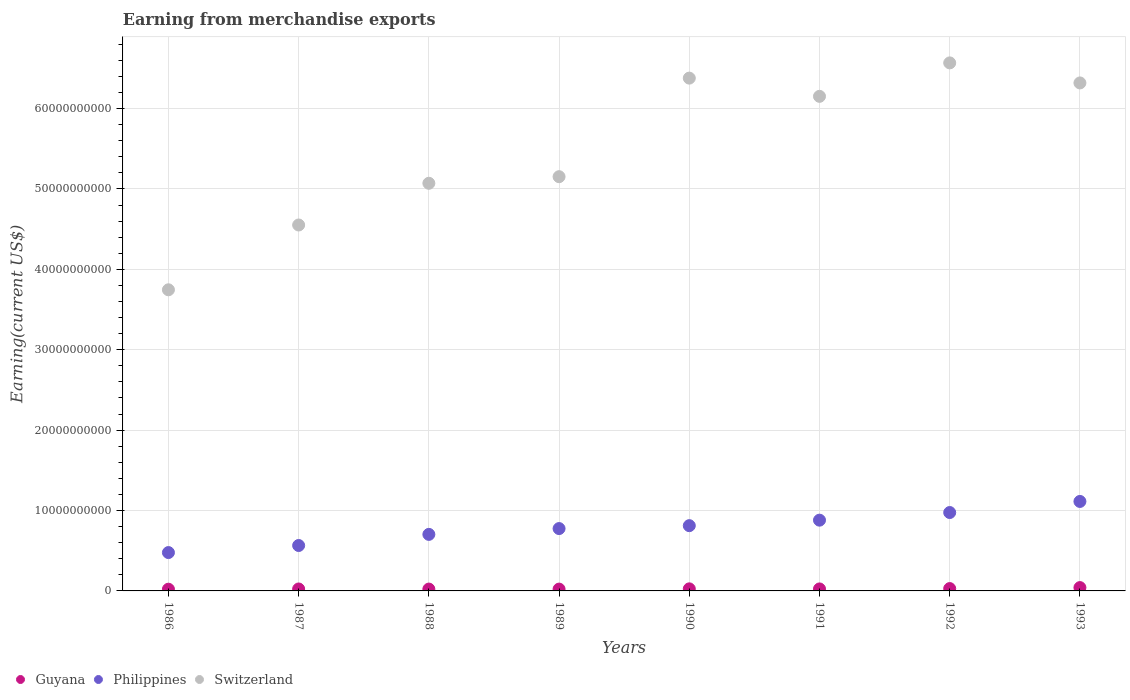How many different coloured dotlines are there?
Keep it short and to the point. 3. Is the number of dotlines equal to the number of legend labels?
Your answer should be very brief. Yes. What is the amount earned from merchandise exports in Switzerland in 1988?
Your response must be concise. 5.07e+1. Across all years, what is the maximum amount earned from merchandise exports in Guyana?
Offer a very short reply. 4.14e+08. Across all years, what is the minimum amount earned from merchandise exports in Philippines?
Give a very brief answer. 4.77e+09. In which year was the amount earned from merchandise exports in Switzerland maximum?
Your response must be concise. 1992. What is the total amount earned from merchandise exports in Guyana in the graph?
Ensure brevity in your answer.  2.12e+09. What is the difference between the amount earned from merchandise exports in Switzerland in 1986 and that in 1991?
Offer a very short reply. -2.41e+1. What is the difference between the amount earned from merchandise exports in Philippines in 1993 and the amount earned from merchandise exports in Guyana in 1992?
Offer a very short reply. 1.08e+1. What is the average amount earned from merchandise exports in Switzerland per year?
Give a very brief answer. 5.49e+1. In the year 1988, what is the difference between the amount earned from merchandise exports in Switzerland and amount earned from merchandise exports in Guyana?
Ensure brevity in your answer.  5.05e+1. In how many years, is the amount earned from merchandise exports in Guyana greater than 54000000000 US$?
Your answer should be compact. 0. What is the ratio of the amount earned from merchandise exports in Switzerland in 1986 to that in 1988?
Give a very brief answer. 0.74. Is the difference between the amount earned from merchandise exports in Switzerland in 1991 and 1993 greater than the difference between the amount earned from merchandise exports in Guyana in 1991 and 1993?
Provide a succinct answer. No. What is the difference between the highest and the second highest amount earned from merchandise exports in Philippines?
Provide a short and direct response. 1.38e+09. What is the difference between the highest and the lowest amount earned from merchandise exports in Guyana?
Your answer should be very brief. 2.00e+08. Is it the case that in every year, the sum of the amount earned from merchandise exports in Philippines and amount earned from merchandise exports in Guyana  is greater than the amount earned from merchandise exports in Switzerland?
Make the answer very short. No. Does the amount earned from merchandise exports in Philippines monotonically increase over the years?
Keep it short and to the point. Yes. Is the amount earned from merchandise exports in Switzerland strictly greater than the amount earned from merchandise exports in Philippines over the years?
Ensure brevity in your answer.  Yes. Is the amount earned from merchandise exports in Guyana strictly less than the amount earned from merchandise exports in Philippines over the years?
Offer a terse response. Yes. How many dotlines are there?
Ensure brevity in your answer.  3. What is the difference between two consecutive major ticks on the Y-axis?
Provide a short and direct response. 1.00e+1. Does the graph contain any zero values?
Provide a short and direct response. No. Where does the legend appear in the graph?
Your response must be concise. Bottom left. How are the legend labels stacked?
Your answer should be very brief. Horizontal. What is the title of the graph?
Provide a succinct answer. Earning from merchandise exports. Does "Korea (Democratic)" appear as one of the legend labels in the graph?
Offer a very short reply. No. What is the label or title of the Y-axis?
Ensure brevity in your answer.  Earning(current US$). What is the Earning(current US$) in Guyana in 1986?
Make the answer very short. 2.14e+08. What is the Earning(current US$) of Philippines in 1986?
Your answer should be very brief. 4.77e+09. What is the Earning(current US$) of Switzerland in 1986?
Provide a succinct answer. 3.75e+1. What is the Earning(current US$) of Guyana in 1987?
Provide a succinct answer. 2.42e+08. What is the Earning(current US$) of Philippines in 1987?
Provide a succinct answer. 5.65e+09. What is the Earning(current US$) of Switzerland in 1987?
Your answer should be very brief. 4.55e+1. What is the Earning(current US$) in Guyana in 1988?
Make the answer very short. 2.30e+08. What is the Earning(current US$) of Philippines in 1988?
Offer a very short reply. 7.03e+09. What is the Earning(current US$) of Switzerland in 1988?
Offer a very short reply. 5.07e+1. What is the Earning(current US$) in Guyana in 1989?
Offer a terse response. 2.27e+08. What is the Earning(current US$) in Philippines in 1989?
Your answer should be compact. 7.76e+09. What is the Earning(current US$) in Switzerland in 1989?
Offer a very short reply. 5.15e+1. What is the Earning(current US$) of Guyana in 1990?
Offer a very short reply. 2.57e+08. What is the Earning(current US$) in Philippines in 1990?
Keep it short and to the point. 8.12e+09. What is the Earning(current US$) in Switzerland in 1990?
Your answer should be compact. 6.38e+1. What is the Earning(current US$) in Guyana in 1991?
Keep it short and to the point. 2.48e+08. What is the Earning(current US$) in Philippines in 1991?
Your answer should be compact. 8.80e+09. What is the Earning(current US$) in Switzerland in 1991?
Provide a short and direct response. 6.15e+1. What is the Earning(current US$) of Guyana in 1992?
Keep it short and to the point. 2.92e+08. What is the Earning(current US$) in Philippines in 1992?
Give a very brief answer. 9.75e+09. What is the Earning(current US$) in Switzerland in 1992?
Offer a very short reply. 6.57e+1. What is the Earning(current US$) of Guyana in 1993?
Keep it short and to the point. 4.14e+08. What is the Earning(current US$) of Philippines in 1993?
Offer a terse response. 1.11e+1. What is the Earning(current US$) in Switzerland in 1993?
Make the answer very short. 6.32e+1. Across all years, what is the maximum Earning(current US$) of Guyana?
Provide a succinct answer. 4.14e+08. Across all years, what is the maximum Earning(current US$) in Philippines?
Keep it short and to the point. 1.11e+1. Across all years, what is the maximum Earning(current US$) in Switzerland?
Make the answer very short. 6.57e+1. Across all years, what is the minimum Earning(current US$) of Guyana?
Ensure brevity in your answer.  2.14e+08. Across all years, what is the minimum Earning(current US$) of Philippines?
Your answer should be very brief. 4.77e+09. Across all years, what is the minimum Earning(current US$) in Switzerland?
Your answer should be compact. 3.75e+1. What is the total Earning(current US$) of Guyana in the graph?
Offer a terse response. 2.12e+09. What is the total Earning(current US$) of Philippines in the graph?
Keep it short and to the point. 6.30e+1. What is the total Earning(current US$) in Switzerland in the graph?
Provide a short and direct response. 4.39e+11. What is the difference between the Earning(current US$) in Guyana in 1986 and that in 1987?
Your answer should be compact. -2.80e+07. What is the difference between the Earning(current US$) in Philippines in 1986 and that in 1987?
Make the answer very short. -8.78e+08. What is the difference between the Earning(current US$) of Switzerland in 1986 and that in 1987?
Your answer should be very brief. -8.06e+09. What is the difference between the Earning(current US$) in Guyana in 1986 and that in 1988?
Your answer should be compact. -1.60e+07. What is the difference between the Earning(current US$) of Philippines in 1986 and that in 1988?
Provide a short and direct response. -2.26e+09. What is the difference between the Earning(current US$) in Switzerland in 1986 and that in 1988?
Your response must be concise. -1.32e+1. What is the difference between the Earning(current US$) of Guyana in 1986 and that in 1989?
Give a very brief answer. -1.30e+07. What is the difference between the Earning(current US$) in Philippines in 1986 and that in 1989?
Your answer should be very brief. -2.98e+09. What is the difference between the Earning(current US$) in Switzerland in 1986 and that in 1989?
Provide a succinct answer. -1.41e+1. What is the difference between the Earning(current US$) in Guyana in 1986 and that in 1990?
Your answer should be compact. -4.30e+07. What is the difference between the Earning(current US$) of Philippines in 1986 and that in 1990?
Offer a very short reply. -3.35e+09. What is the difference between the Earning(current US$) in Switzerland in 1986 and that in 1990?
Your response must be concise. -2.63e+1. What is the difference between the Earning(current US$) of Guyana in 1986 and that in 1991?
Provide a succinct answer. -3.40e+07. What is the difference between the Earning(current US$) in Philippines in 1986 and that in 1991?
Your response must be concise. -4.03e+09. What is the difference between the Earning(current US$) of Switzerland in 1986 and that in 1991?
Offer a very short reply. -2.41e+1. What is the difference between the Earning(current US$) of Guyana in 1986 and that in 1992?
Give a very brief answer. -7.80e+07. What is the difference between the Earning(current US$) of Philippines in 1986 and that in 1992?
Make the answer very short. -4.98e+09. What is the difference between the Earning(current US$) in Switzerland in 1986 and that in 1992?
Offer a very short reply. -2.82e+1. What is the difference between the Earning(current US$) of Guyana in 1986 and that in 1993?
Make the answer very short. -2.00e+08. What is the difference between the Earning(current US$) in Philippines in 1986 and that in 1993?
Ensure brevity in your answer.  -6.36e+09. What is the difference between the Earning(current US$) in Switzerland in 1986 and that in 1993?
Your response must be concise. -2.57e+1. What is the difference between the Earning(current US$) in Philippines in 1987 and that in 1988?
Offer a very short reply. -1.38e+09. What is the difference between the Earning(current US$) of Switzerland in 1987 and that in 1988?
Give a very brief answer. -5.19e+09. What is the difference between the Earning(current US$) in Guyana in 1987 and that in 1989?
Your answer should be compact. 1.50e+07. What is the difference between the Earning(current US$) of Philippines in 1987 and that in 1989?
Your response must be concise. -2.11e+09. What is the difference between the Earning(current US$) in Switzerland in 1987 and that in 1989?
Provide a succinct answer. -6.01e+09. What is the difference between the Earning(current US$) in Guyana in 1987 and that in 1990?
Give a very brief answer. -1.50e+07. What is the difference between the Earning(current US$) in Philippines in 1987 and that in 1990?
Offer a terse response. -2.47e+09. What is the difference between the Earning(current US$) in Switzerland in 1987 and that in 1990?
Make the answer very short. -1.83e+1. What is the difference between the Earning(current US$) of Guyana in 1987 and that in 1991?
Offer a very short reply. -6.00e+06. What is the difference between the Earning(current US$) in Philippines in 1987 and that in 1991?
Your answer should be very brief. -3.15e+09. What is the difference between the Earning(current US$) of Switzerland in 1987 and that in 1991?
Provide a short and direct response. -1.60e+1. What is the difference between the Earning(current US$) in Guyana in 1987 and that in 1992?
Ensure brevity in your answer.  -5.00e+07. What is the difference between the Earning(current US$) in Philippines in 1987 and that in 1992?
Your answer should be compact. -4.10e+09. What is the difference between the Earning(current US$) of Switzerland in 1987 and that in 1992?
Provide a succinct answer. -2.02e+1. What is the difference between the Earning(current US$) of Guyana in 1987 and that in 1993?
Give a very brief answer. -1.72e+08. What is the difference between the Earning(current US$) of Philippines in 1987 and that in 1993?
Offer a terse response. -5.48e+09. What is the difference between the Earning(current US$) of Switzerland in 1987 and that in 1993?
Your answer should be compact. -1.77e+1. What is the difference between the Earning(current US$) in Guyana in 1988 and that in 1989?
Offer a terse response. 3.00e+06. What is the difference between the Earning(current US$) in Philippines in 1988 and that in 1989?
Provide a short and direct response. -7.23e+08. What is the difference between the Earning(current US$) in Switzerland in 1988 and that in 1989?
Give a very brief answer. -8.21e+08. What is the difference between the Earning(current US$) of Guyana in 1988 and that in 1990?
Your answer should be very brief. -2.70e+07. What is the difference between the Earning(current US$) in Philippines in 1988 and that in 1990?
Provide a short and direct response. -1.08e+09. What is the difference between the Earning(current US$) of Switzerland in 1988 and that in 1990?
Offer a very short reply. -1.31e+1. What is the difference between the Earning(current US$) in Guyana in 1988 and that in 1991?
Keep it short and to the point. -1.80e+07. What is the difference between the Earning(current US$) of Philippines in 1988 and that in 1991?
Offer a very short reply. -1.77e+09. What is the difference between the Earning(current US$) of Switzerland in 1988 and that in 1991?
Provide a succinct answer. -1.08e+1. What is the difference between the Earning(current US$) in Guyana in 1988 and that in 1992?
Your response must be concise. -6.20e+07. What is the difference between the Earning(current US$) of Philippines in 1988 and that in 1992?
Keep it short and to the point. -2.72e+09. What is the difference between the Earning(current US$) of Switzerland in 1988 and that in 1992?
Keep it short and to the point. -1.50e+1. What is the difference between the Earning(current US$) in Guyana in 1988 and that in 1993?
Make the answer very short. -1.84e+08. What is the difference between the Earning(current US$) in Philippines in 1988 and that in 1993?
Provide a succinct answer. -4.10e+09. What is the difference between the Earning(current US$) of Switzerland in 1988 and that in 1993?
Make the answer very short. -1.25e+1. What is the difference between the Earning(current US$) in Guyana in 1989 and that in 1990?
Your answer should be compact. -3.00e+07. What is the difference between the Earning(current US$) of Philippines in 1989 and that in 1990?
Your answer should be compact. -3.62e+08. What is the difference between the Earning(current US$) of Switzerland in 1989 and that in 1990?
Make the answer very short. -1.23e+1. What is the difference between the Earning(current US$) in Guyana in 1989 and that in 1991?
Give a very brief answer. -2.10e+07. What is the difference between the Earning(current US$) of Philippines in 1989 and that in 1991?
Provide a short and direct response. -1.05e+09. What is the difference between the Earning(current US$) of Switzerland in 1989 and that in 1991?
Ensure brevity in your answer.  -9.99e+09. What is the difference between the Earning(current US$) in Guyana in 1989 and that in 1992?
Provide a short and direct response. -6.50e+07. What is the difference between the Earning(current US$) in Philippines in 1989 and that in 1992?
Provide a succinct answer. -2.00e+09. What is the difference between the Earning(current US$) in Switzerland in 1989 and that in 1992?
Ensure brevity in your answer.  -1.42e+1. What is the difference between the Earning(current US$) of Guyana in 1989 and that in 1993?
Provide a short and direct response. -1.87e+08. What is the difference between the Earning(current US$) in Philippines in 1989 and that in 1993?
Your response must be concise. -3.37e+09. What is the difference between the Earning(current US$) in Switzerland in 1989 and that in 1993?
Offer a terse response. -1.17e+1. What is the difference between the Earning(current US$) in Guyana in 1990 and that in 1991?
Provide a succinct answer. 9.00e+06. What is the difference between the Earning(current US$) in Philippines in 1990 and that in 1991?
Provide a succinct answer. -6.84e+08. What is the difference between the Earning(current US$) of Switzerland in 1990 and that in 1991?
Your answer should be compact. 2.27e+09. What is the difference between the Earning(current US$) in Guyana in 1990 and that in 1992?
Provide a succinct answer. -3.50e+07. What is the difference between the Earning(current US$) in Philippines in 1990 and that in 1992?
Your response must be concise. -1.63e+09. What is the difference between the Earning(current US$) in Switzerland in 1990 and that in 1992?
Offer a terse response. -1.89e+09. What is the difference between the Earning(current US$) in Guyana in 1990 and that in 1993?
Offer a very short reply. -1.57e+08. What is the difference between the Earning(current US$) of Philippines in 1990 and that in 1993?
Your response must be concise. -3.01e+09. What is the difference between the Earning(current US$) of Switzerland in 1990 and that in 1993?
Provide a succinct answer. 5.99e+08. What is the difference between the Earning(current US$) in Guyana in 1991 and that in 1992?
Provide a succinct answer. -4.40e+07. What is the difference between the Earning(current US$) in Philippines in 1991 and that in 1992?
Make the answer very short. -9.50e+08. What is the difference between the Earning(current US$) of Switzerland in 1991 and that in 1992?
Your response must be concise. -4.16e+09. What is the difference between the Earning(current US$) of Guyana in 1991 and that in 1993?
Ensure brevity in your answer.  -1.66e+08. What is the difference between the Earning(current US$) of Philippines in 1991 and that in 1993?
Your response must be concise. -2.33e+09. What is the difference between the Earning(current US$) of Switzerland in 1991 and that in 1993?
Keep it short and to the point. -1.67e+09. What is the difference between the Earning(current US$) of Guyana in 1992 and that in 1993?
Your response must be concise. -1.22e+08. What is the difference between the Earning(current US$) in Philippines in 1992 and that in 1993?
Ensure brevity in your answer.  -1.38e+09. What is the difference between the Earning(current US$) of Switzerland in 1992 and that in 1993?
Ensure brevity in your answer.  2.49e+09. What is the difference between the Earning(current US$) in Guyana in 1986 and the Earning(current US$) in Philippines in 1987?
Your answer should be compact. -5.44e+09. What is the difference between the Earning(current US$) of Guyana in 1986 and the Earning(current US$) of Switzerland in 1987?
Ensure brevity in your answer.  -4.53e+1. What is the difference between the Earning(current US$) in Philippines in 1986 and the Earning(current US$) in Switzerland in 1987?
Give a very brief answer. -4.07e+1. What is the difference between the Earning(current US$) of Guyana in 1986 and the Earning(current US$) of Philippines in 1988?
Your answer should be very brief. -6.82e+09. What is the difference between the Earning(current US$) of Guyana in 1986 and the Earning(current US$) of Switzerland in 1988?
Give a very brief answer. -5.05e+1. What is the difference between the Earning(current US$) in Philippines in 1986 and the Earning(current US$) in Switzerland in 1988?
Offer a very short reply. -4.59e+1. What is the difference between the Earning(current US$) in Guyana in 1986 and the Earning(current US$) in Philippines in 1989?
Make the answer very short. -7.54e+09. What is the difference between the Earning(current US$) in Guyana in 1986 and the Earning(current US$) in Switzerland in 1989?
Keep it short and to the point. -5.13e+1. What is the difference between the Earning(current US$) of Philippines in 1986 and the Earning(current US$) of Switzerland in 1989?
Provide a short and direct response. -4.68e+1. What is the difference between the Earning(current US$) in Guyana in 1986 and the Earning(current US$) in Philippines in 1990?
Offer a very short reply. -7.90e+09. What is the difference between the Earning(current US$) in Guyana in 1986 and the Earning(current US$) in Switzerland in 1990?
Ensure brevity in your answer.  -6.36e+1. What is the difference between the Earning(current US$) of Philippines in 1986 and the Earning(current US$) of Switzerland in 1990?
Provide a succinct answer. -5.90e+1. What is the difference between the Earning(current US$) of Guyana in 1986 and the Earning(current US$) of Philippines in 1991?
Keep it short and to the point. -8.59e+09. What is the difference between the Earning(current US$) in Guyana in 1986 and the Earning(current US$) in Switzerland in 1991?
Your answer should be very brief. -6.13e+1. What is the difference between the Earning(current US$) in Philippines in 1986 and the Earning(current US$) in Switzerland in 1991?
Keep it short and to the point. -5.67e+1. What is the difference between the Earning(current US$) of Guyana in 1986 and the Earning(current US$) of Philippines in 1992?
Provide a short and direct response. -9.54e+09. What is the difference between the Earning(current US$) of Guyana in 1986 and the Earning(current US$) of Switzerland in 1992?
Provide a short and direct response. -6.55e+1. What is the difference between the Earning(current US$) in Philippines in 1986 and the Earning(current US$) in Switzerland in 1992?
Your answer should be very brief. -6.09e+1. What is the difference between the Earning(current US$) in Guyana in 1986 and the Earning(current US$) in Philippines in 1993?
Your answer should be compact. -1.09e+1. What is the difference between the Earning(current US$) of Guyana in 1986 and the Earning(current US$) of Switzerland in 1993?
Offer a terse response. -6.30e+1. What is the difference between the Earning(current US$) of Philippines in 1986 and the Earning(current US$) of Switzerland in 1993?
Keep it short and to the point. -5.84e+1. What is the difference between the Earning(current US$) in Guyana in 1987 and the Earning(current US$) in Philippines in 1988?
Keep it short and to the point. -6.79e+09. What is the difference between the Earning(current US$) in Guyana in 1987 and the Earning(current US$) in Switzerland in 1988?
Offer a terse response. -5.05e+1. What is the difference between the Earning(current US$) of Philippines in 1987 and the Earning(current US$) of Switzerland in 1988?
Your response must be concise. -4.51e+1. What is the difference between the Earning(current US$) in Guyana in 1987 and the Earning(current US$) in Philippines in 1989?
Offer a very short reply. -7.51e+09. What is the difference between the Earning(current US$) of Guyana in 1987 and the Earning(current US$) of Switzerland in 1989?
Give a very brief answer. -5.13e+1. What is the difference between the Earning(current US$) of Philippines in 1987 and the Earning(current US$) of Switzerland in 1989?
Keep it short and to the point. -4.59e+1. What is the difference between the Earning(current US$) in Guyana in 1987 and the Earning(current US$) in Philippines in 1990?
Provide a short and direct response. -7.88e+09. What is the difference between the Earning(current US$) in Guyana in 1987 and the Earning(current US$) in Switzerland in 1990?
Ensure brevity in your answer.  -6.35e+1. What is the difference between the Earning(current US$) of Philippines in 1987 and the Earning(current US$) of Switzerland in 1990?
Provide a succinct answer. -5.81e+1. What is the difference between the Earning(current US$) of Guyana in 1987 and the Earning(current US$) of Philippines in 1991?
Your response must be concise. -8.56e+09. What is the difference between the Earning(current US$) in Guyana in 1987 and the Earning(current US$) in Switzerland in 1991?
Your answer should be very brief. -6.13e+1. What is the difference between the Earning(current US$) of Philippines in 1987 and the Earning(current US$) of Switzerland in 1991?
Your answer should be compact. -5.59e+1. What is the difference between the Earning(current US$) of Guyana in 1987 and the Earning(current US$) of Philippines in 1992?
Offer a very short reply. -9.51e+09. What is the difference between the Earning(current US$) of Guyana in 1987 and the Earning(current US$) of Switzerland in 1992?
Provide a short and direct response. -6.54e+1. What is the difference between the Earning(current US$) of Philippines in 1987 and the Earning(current US$) of Switzerland in 1992?
Your response must be concise. -6.00e+1. What is the difference between the Earning(current US$) of Guyana in 1987 and the Earning(current US$) of Philippines in 1993?
Offer a very short reply. -1.09e+1. What is the difference between the Earning(current US$) of Guyana in 1987 and the Earning(current US$) of Switzerland in 1993?
Keep it short and to the point. -6.29e+1. What is the difference between the Earning(current US$) of Philippines in 1987 and the Earning(current US$) of Switzerland in 1993?
Keep it short and to the point. -5.75e+1. What is the difference between the Earning(current US$) of Guyana in 1988 and the Earning(current US$) of Philippines in 1989?
Keep it short and to the point. -7.52e+09. What is the difference between the Earning(current US$) of Guyana in 1988 and the Earning(current US$) of Switzerland in 1989?
Offer a very short reply. -5.13e+1. What is the difference between the Earning(current US$) of Philippines in 1988 and the Earning(current US$) of Switzerland in 1989?
Provide a short and direct response. -4.45e+1. What is the difference between the Earning(current US$) in Guyana in 1988 and the Earning(current US$) in Philippines in 1990?
Offer a very short reply. -7.89e+09. What is the difference between the Earning(current US$) in Guyana in 1988 and the Earning(current US$) in Switzerland in 1990?
Give a very brief answer. -6.36e+1. What is the difference between the Earning(current US$) of Philippines in 1988 and the Earning(current US$) of Switzerland in 1990?
Provide a succinct answer. -5.68e+1. What is the difference between the Earning(current US$) of Guyana in 1988 and the Earning(current US$) of Philippines in 1991?
Ensure brevity in your answer.  -8.57e+09. What is the difference between the Earning(current US$) in Guyana in 1988 and the Earning(current US$) in Switzerland in 1991?
Ensure brevity in your answer.  -6.13e+1. What is the difference between the Earning(current US$) of Philippines in 1988 and the Earning(current US$) of Switzerland in 1991?
Keep it short and to the point. -5.45e+1. What is the difference between the Earning(current US$) in Guyana in 1988 and the Earning(current US$) in Philippines in 1992?
Your answer should be compact. -9.52e+09. What is the difference between the Earning(current US$) in Guyana in 1988 and the Earning(current US$) in Switzerland in 1992?
Provide a short and direct response. -6.54e+1. What is the difference between the Earning(current US$) in Philippines in 1988 and the Earning(current US$) in Switzerland in 1992?
Your response must be concise. -5.86e+1. What is the difference between the Earning(current US$) in Guyana in 1988 and the Earning(current US$) in Philippines in 1993?
Your answer should be very brief. -1.09e+1. What is the difference between the Earning(current US$) in Guyana in 1988 and the Earning(current US$) in Switzerland in 1993?
Your answer should be very brief. -6.30e+1. What is the difference between the Earning(current US$) in Philippines in 1988 and the Earning(current US$) in Switzerland in 1993?
Your answer should be compact. -5.62e+1. What is the difference between the Earning(current US$) in Guyana in 1989 and the Earning(current US$) in Philippines in 1990?
Provide a succinct answer. -7.89e+09. What is the difference between the Earning(current US$) of Guyana in 1989 and the Earning(current US$) of Switzerland in 1990?
Ensure brevity in your answer.  -6.36e+1. What is the difference between the Earning(current US$) of Philippines in 1989 and the Earning(current US$) of Switzerland in 1990?
Your response must be concise. -5.60e+1. What is the difference between the Earning(current US$) in Guyana in 1989 and the Earning(current US$) in Philippines in 1991?
Your answer should be very brief. -8.57e+09. What is the difference between the Earning(current US$) in Guyana in 1989 and the Earning(current US$) in Switzerland in 1991?
Give a very brief answer. -6.13e+1. What is the difference between the Earning(current US$) of Philippines in 1989 and the Earning(current US$) of Switzerland in 1991?
Ensure brevity in your answer.  -5.38e+1. What is the difference between the Earning(current US$) in Guyana in 1989 and the Earning(current US$) in Philippines in 1992?
Your answer should be compact. -9.52e+09. What is the difference between the Earning(current US$) of Guyana in 1989 and the Earning(current US$) of Switzerland in 1992?
Ensure brevity in your answer.  -6.55e+1. What is the difference between the Earning(current US$) in Philippines in 1989 and the Earning(current US$) in Switzerland in 1992?
Keep it short and to the point. -5.79e+1. What is the difference between the Earning(current US$) in Guyana in 1989 and the Earning(current US$) in Philippines in 1993?
Provide a succinct answer. -1.09e+1. What is the difference between the Earning(current US$) of Guyana in 1989 and the Earning(current US$) of Switzerland in 1993?
Your answer should be compact. -6.30e+1. What is the difference between the Earning(current US$) of Philippines in 1989 and the Earning(current US$) of Switzerland in 1993?
Ensure brevity in your answer.  -5.54e+1. What is the difference between the Earning(current US$) of Guyana in 1990 and the Earning(current US$) of Philippines in 1991?
Your answer should be very brief. -8.54e+09. What is the difference between the Earning(current US$) in Guyana in 1990 and the Earning(current US$) in Switzerland in 1991?
Make the answer very short. -6.13e+1. What is the difference between the Earning(current US$) in Philippines in 1990 and the Earning(current US$) in Switzerland in 1991?
Provide a succinct answer. -5.34e+1. What is the difference between the Earning(current US$) of Guyana in 1990 and the Earning(current US$) of Philippines in 1992?
Ensure brevity in your answer.  -9.49e+09. What is the difference between the Earning(current US$) in Guyana in 1990 and the Earning(current US$) in Switzerland in 1992?
Your answer should be very brief. -6.54e+1. What is the difference between the Earning(current US$) of Philippines in 1990 and the Earning(current US$) of Switzerland in 1992?
Provide a short and direct response. -5.76e+1. What is the difference between the Earning(current US$) of Guyana in 1990 and the Earning(current US$) of Philippines in 1993?
Provide a succinct answer. -1.09e+1. What is the difference between the Earning(current US$) in Guyana in 1990 and the Earning(current US$) in Switzerland in 1993?
Provide a short and direct response. -6.29e+1. What is the difference between the Earning(current US$) of Philippines in 1990 and the Earning(current US$) of Switzerland in 1993?
Offer a very short reply. -5.51e+1. What is the difference between the Earning(current US$) of Guyana in 1991 and the Earning(current US$) of Philippines in 1992?
Make the answer very short. -9.50e+09. What is the difference between the Earning(current US$) of Guyana in 1991 and the Earning(current US$) of Switzerland in 1992?
Your response must be concise. -6.54e+1. What is the difference between the Earning(current US$) in Philippines in 1991 and the Earning(current US$) in Switzerland in 1992?
Offer a very short reply. -5.69e+1. What is the difference between the Earning(current US$) of Guyana in 1991 and the Earning(current US$) of Philippines in 1993?
Offer a very short reply. -1.09e+1. What is the difference between the Earning(current US$) of Guyana in 1991 and the Earning(current US$) of Switzerland in 1993?
Offer a very short reply. -6.29e+1. What is the difference between the Earning(current US$) of Philippines in 1991 and the Earning(current US$) of Switzerland in 1993?
Ensure brevity in your answer.  -5.44e+1. What is the difference between the Earning(current US$) of Guyana in 1992 and the Earning(current US$) of Philippines in 1993?
Make the answer very short. -1.08e+1. What is the difference between the Earning(current US$) of Guyana in 1992 and the Earning(current US$) of Switzerland in 1993?
Make the answer very short. -6.29e+1. What is the difference between the Earning(current US$) of Philippines in 1992 and the Earning(current US$) of Switzerland in 1993?
Provide a succinct answer. -5.34e+1. What is the average Earning(current US$) of Guyana per year?
Your answer should be compact. 2.66e+08. What is the average Earning(current US$) in Philippines per year?
Make the answer very short. 7.88e+09. What is the average Earning(current US$) in Switzerland per year?
Your answer should be compact. 5.49e+1. In the year 1986, what is the difference between the Earning(current US$) of Guyana and Earning(current US$) of Philippines?
Offer a very short reply. -4.56e+09. In the year 1986, what is the difference between the Earning(current US$) in Guyana and Earning(current US$) in Switzerland?
Provide a short and direct response. -3.72e+1. In the year 1986, what is the difference between the Earning(current US$) in Philippines and Earning(current US$) in Switzerland?
Your answer should be very brief. -3.27e+1. In the year 1987, what is the difference between the Earning(current US$) in Guyana and Earning(current US$) in Philippines?
Provide a succinct answer. -5.41e+09. In the year 1987, what is the difference between the Earning(current US$) of Guyana and Earning(current US$) of Switzerland?
Your response must be concise. -4.53e+1. In the year 1987, what is the difference between the Earning(current US$) of Philippines and Earning(current US$) of Switzerland?
Provide a short and direct response. -3.99e+1. In the year 1988, what is the difference between the Earning(current US$) of Guyana and Earning(current US$) of Philippines?
Your answer should be compact. -6.80e+09. In the year 1988, what is the difference between the Earning(current US$) of Guyana and Earning(current US$) of Switzerland?
Your answer should be very brief. -5.05e+1. In the year 1988, what is the difference between the Earning(current US$) in Philippines and Earning(current US$) in Switzerland?
Your answer should be compact. -4.37e+1. In the year 1989, what is the difference between the Earning(current US$) in Guyana and Earning(current US$) in Philippines?
Ensure brevity in your answer.  -7.53e+09. In the year 1989, what is the difference between the Earning(current US$) in Guyana and Earning(current US$) in Switzerland?
Provide a succinct answer. -5.13e+1. In the year 1989, what is the difference between the Earning(current US$) in Philippines and Earning(current US$) in Switzerland?
Your answer should be very brief. -4.38e+1. In the year 1990, what is the difference between the Earning(current US$) of Guyana and Earning(current US$) of Philippines?
Ensure brevity in your answer.  -7.86e+09. In the year 1990, what is the difference between the Earning(current US$) of Guyana and Earning(current US$) of Switzerland?
Offer a very short reply. -6.35e+1. In the year 1990, what is the difference between the Earning(current US$) in Philippines and Earning(current US$) in Switzerland?
Keep it short and to the point. -5.57e+1. In the year 1991, what is the difference between the Earning(current US$) in Guyana and Earning(current US$) in Philippines?
Make the answer very short. -8.55e+09. In the year 1991, what is the difference between the Earning(current US$) of Guyana and Earning(current US$) of Switzerland?
Your answer should be compact. -6.13e+1. In the year 1991, what is the difference between the Earning(current US$) in Philippines and Earning(current US$) in Switzerland?
Your response must be concise. -5.27e+1. In the year 1992, what is the difference between the Earning(current US$) of Guyana and Earning(current US$) of Philippines?
Your response must be concise. -9.46e+09. In the year 1992, what is the difference between the Earning(current US$) in Guyana and Earning(current US$) in Switzerland?
Your answer should be very brief. -6.54e+1. In the year 1992, what is the difference between the Earning(current US$) of Philippines and Earning(current US$) of Switzerland?
Your answer should be compact. -5.59e+1. In the year 1993, what is the difference between the Earning(current US$) in Guyana and Earning(current US$) in Philippines?
Give a very brief answer. -1.07e+1. In the year 1993, what is the difference between the Earning(current US$) of Guyana and Earning(current US$) of Switzerland?
Provide a short and direct response. -6.28e+1. In the year 1993, what is the difference between the Earning(current US$) in Philippines and Earning(current US$) in Switzerland?
Offer a terse response. -5.21e+1. What is the ratio of the Earning(current US$) in Guyana in 1986 to that in 1987?
Your answer should be compact. 0.88. What is the ratio of the Earning(current US$) of Philippines in 1986 to that in 1987?
Give a very brief answer. 0.84. What is the ratio of the Earning(current US$) of Switzerland in 1986 to that in 1987?
Offer a terse response. 0.82. What is the ratio of the Earning(current US$) of Guyana in 1986 to that in 1988?
Your response must be concise. 0.93. What is the ratio of the Earning(current US$) in Philippines in 1986 to that in 1988?
Make the answer very short. 0.68. What is the ratio of the Earning(current US$) in Switzerland in 1986 to that in 1988?
Give a very brief answer. 0.74. What is the ratio of the Earning(current US$) of Guyana in 1986 to that in 1989?
Make the answer very short. 0.94. What is the ratio of the Earning(current US$) of Philippines in 1986 to that in 1989?
Provide a succinct answer. 0.62. What is the ratio of the Earning(current US$) of Switzerland in 1986 to that in 1989?
Your answer should be very brief. 0.73. What is the ratio of the Earning(current US$) of Guyana in 1986 to that in 1990?
Give a very brief answer. 0.83. What is the ratio of the Earning(current US$) of Philippines in 1986 to that in 1990?
Make the answer very short. 0.59. What is the ratio of the Earning(current US$) of Switzerland in 1986 to that in 1990?
Give a very brief answer. 0.59. What is the ratio of the Earning(current US$) of Guyana in 1986 to that in 1991?
Ensure brevity in your answer.  0.86. What is the ratio of the Earning(current US$) of Philippines in 1986 to that in 1991?
Your response must be concise. 0.54. What is the ratio of the Earning(current US$) of Switzerland in 1986 to that in 1991?
Provide a succinct answer. 0.61. What is the ratio of the Earning(current US$) in Guyana in 1986 to that in 1992?
Your answer should be very brief. 0.73. What is the ratio of the Earning(current US$) of Philippines in 1986 to that in 1992?
Offer a very short reply. 0.49. What is the ratio of the Earning(current US$) of Switzerland in 1986 to that in 1992?
Provide a short and direct response. 0.57. What is the ratio of the Earning(current US$) in Guyana in 1986 to that in 1993?
Offer a very short reply. 0.52. What is the ratio of the Earning(current US$) of Philippines in 1986 to that in 1993?
Your answer should be very brief. 0.43. What is the ratio of the Earning(current US$) of Switzerland in 1986 to that in 1993?
Your answer should be very brief. 0.59. What is the ratio of the Earning(current US$) of Guyana in 1987 to that in 1988?
Make the answer very short. 1.05. What is the ratio of the Earning(current US$) in Philippines in 1987 to that in 1988?
Keep it short and to the point. 0.8. What is the ratio of the Earning(current US$) of Switzerland in 1987 to that in 1988?
Ensure brevity in your answer.  0.9. What is the ratio of the Earning(current US$) of Guyana in 1987 to that in 1989?
Offer a terse response. 1.07. What is the ratio of the Earning(current US$) in Philippines in 1987 to that in 1989?
Make the answer very short. 0.73. What is the ratio of the Earning(current US$) in Switzerland in 1987 to that in 1989?
Offer a very short reply. 0.88. What is the ratio of the Earning(current US$) of Guyana in 1987 to that in 1990?
Keep it short and to the point. 0.94. What is the ratio of the Earning(current US$) of Philippines in 1987 to that in 1990?
Provide a succinct answer. 0.7. What is the ratio of the Earning(current US$) of Switzerland in 1987 to that in 1990?
Provide a succinct answer. 0.71. What is the ratio of the Earning(current US$) in Guyana in 1987 to that in 1991?
Offer a terse response. 0.98. What is the ratio of the Earning(current US$) in Philippines in 1987 to that in 1991?
Offer a very short reply. 0.64. What is the ratio of the Earning(current US$) in Switzerland in 1987 to that in 1991?
Your response must be concise. 0.74. What is the ratio of the Earning(current US$) of Guyana in 1987 to that in 1992?
Your response must be concise. 0.83. What is the ratio of the Earning(current US$) in Philippines in 1987 to that in 1992?
Keep it short and to the point. 0.58. What is the ratio of the Earning(current US$) of Switzerland in 1987 to that in 1992?
Your answer should be very brief. 0.69. What is the ratio of the Earning(current US$) in Guyana in 1987 to that in 1993?
Offer a very short reply. 0.58. What is the ratio of the Earning(current US$) in Philippines in 1987 to that in 1993?
Your answer should be very brief. 0.51. What is the ratio of the Earning(current US$) of Switzerland in 1987 to that in 1993?
Keep it short and to the point. 0.72. What is the ratio of the Earning(current US$) of Guyana in 1988 to that in 1989?
Provide a short and direct response. 1.01. What is the ratio of the Earning(current US$) of Philippines in 1988 to that in 1989?
Your response must be concise. 0.91. What is the ratio of the Earning(current US$) of Switzerland in 1988 to that in 1989?
Offer a very short reply. 0.98. What is the ratio of the Earning(current US$) of Guyana in 1988 to that in 1990?
Your answer should be very brief. 0.89. What is the ratio of the Earning(current US$) of Philippines in 1988 to that in 1990?
Keep it short and to the point. 0.87. What is the ratio of the Earning(current US$) in Switzerland in 1988 to that in 1990?
Make the answer very short. 0.79. What is the ratio of the Earning(current US$) in Guyana in 1988 to that in 1991?
Provide a succinct answer. 0.93. What is the ratio of the Earning(current US$) of Philippines in 1988 to that in 1991?
Your answer should be very brief. 0.8. What is the ratio of the Earning(current US$) of Switzerland in 1988 to that in 1991?
Offer a very short reply. 0.82. What is the ratio of the Earning(current US$) of Guyana in 1988 to that in 1992?
Ensure brevity in your answer.  0.79. What is the ratio of the Earning(current US$) of Philippines in 1988 to that in 1992?
Your answer should be very brief. 0.72. What is the ratio of the Earning(current US$) in Switzerland in 1988 to that in 1992?
Offer a terse response. 0.77. What is the ratio of the Earning(current US$) of Guyana in 1988 to that in 1993?
Provide a short and direct response. 0.56. What is the ratio of the Earning(current US$) in Philippines in 1988 to that in 1993?
Keep it short and to the point. 0.63. What is the ratio of the Earning(current US$) in Switzerland in 1988 to that in 1993?
Offer a very short reply. 0.8. What is the ratio of the Earning(current US$) of Guyana in 1989 to that in 1990?
Your answer should be compact. 0.88. What is the ratio of the Earning(current US$) of Philippines in 1989 to that in 1990?
Your answer should be very brief. 0.96. What is the ratio of the Earning(current US$) in Switzerland in 1989 to that in 1990?
Your response must be concise. 0.81. What is the ratio of the Earning(current US$) in Guyana in 1989 to that in 1991?
Give a very brief answer. 0.92. What is the ratio of the Earning(current US$) in Philippines in 1989 to that in 1991?
Make the answer very short. 0.88. What is the ratio of the Earning(current US$) of Switzerland in 1989 to that in 1991?
Make the answer very short. 0.84. What is the ratio of the Earning(current US$) in Guyana in 1989 to that in 1992?
Your answer should be very brief. 0.78. What is the ratio of the Earning(current US$) of Philippines in 1989 to that in 1992?
Provide a short and direct response. 0.8. What is the ratio of the Earning(current US$) in Switzerland in 1989 to that in 1992?
Offer a terse response. 0.78. What is the ratio of the Earning(current US$) of Guyana in 1989 to that in 1993?
Provide a succinct answer. 0.55. What is the ratio of the Earning(current US$) of Philippines in 1989 to that in 1993?
Provide a succinct answer. 0.7. What is the ratio of the Earning(current US$) in Switzerland in 1989 to that in 1993?
Provide a short and direct response. 0.82. What is the ratio of the Earning(current US$) of Guyana in 1990 to that in 1991?
Your response must be concise. 1.04. What is the ratio of the Earning(current US$) in Philippines in 1990 to that in 1991?
Provide a succinct answer. 0.92. What is the ratio of the Earning(current US$) of Switzerland in 1990 to that in 1991?
Keep it short and to the point. 1.04. What is the ratio of the Earning(current US$) of Guyana in 1990 to that in 1992?
Offer a terse response. 0.88. What is the ratio of the Earning(current US$) of Philippines in 1990 to that in 1992?
Your answer should be very brief. 0.83. What is the ratio of the Earning(current US$) in Switzerland in 1990 to that in 1992?
Your response must be concise. 0.97. What is the ratio of the Earning(current US$) of Guyana in 1990 to that in 1993?
Provide a short and direct response. 0.62. What is the ratio of the Earning(current US$) in Philippines in 1990 to that in 1993?
Your answer should be compact. 0.73. What is the ratio of the Earning(current US$) of Switzerland in 1990 to that in 1993?
Your answer should be very brief. 1.01. What is the ratio of the Earning(current US$) in Guyana in 1991 to that in 1992?
Your answer should be very brief. 0.85. What is the ratio of the Earning(current US$) of Philippines in 1991 to that in 1992?
Provide a succinct answer. 0.9. What is the ratio of the Earning(current US$) of Switzerland in 1991 to that in 1992?
Offer a very short reply. 0.94. What is the ratio of the Earning(current US$) of Guyana in 1991 to that in 1993?
Your answer should be very brief. 0.6. What is the ratio of the Earning(current US$) of Philippines in 1991 to that in 1993?
Provide a short and direct response. 0.79. What is the ratio of the Earning(current US$) of Switzerland in 1991 to that in 1993?
Offer a terse response. 0.97. What is the ratio of the Earning(current US$) of Guyana in 1992 to that in 1993?
Keep it short and to the point. 0.71. What is the ratio of the Earning(current US$) of Philippines in 1992 to that in 1993?
Make the answer very short. 0.88. What is the ratio of the Earning(current US$) of Switzerland in 1992 to that in 1993?
Provide a short and direct response. 1.04. What is the difference between the highest and the second highest Earning(current US$) of Guyana?
Ensure brevity in your answer.  1.22e+08. What is the difference between the highest and the second highest Earning(current US$) of Philippines?
Your response must be concise. 1.38e+09. What is the difference between the highest and the second highest Earning(current US$) in Switzerland?
Your response must be concise. 1.89e+09. What is the difference between the highest and the lowest Earning(current US$) of Philippines?
Give a very brief answer. 6.36e+09. What is the difference between the highest and the lowest Earning(current US$) in Switzerland?
Provide a short and direct response. 2.82e+1. 